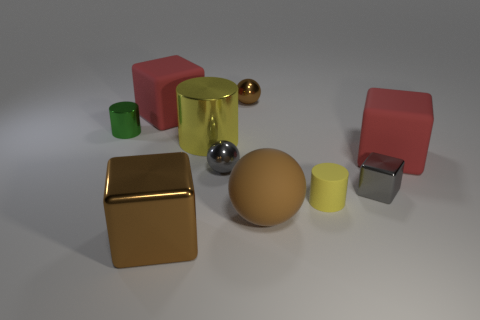Subtract 1 blocks. How many blocks are left? 3 Subtract all cylinders. How many objects are left? 7 Add 8 big gray rubber spheres. How many big gray rubber spheres exist? 8 Subtract 0 blue cubes. How many objects are left? 10 Subtract all large purple objects. Subtract all tiny metal spheres. How many objects are left? 8 Add 6 small brown balls. How many small brown balls are left? 7 